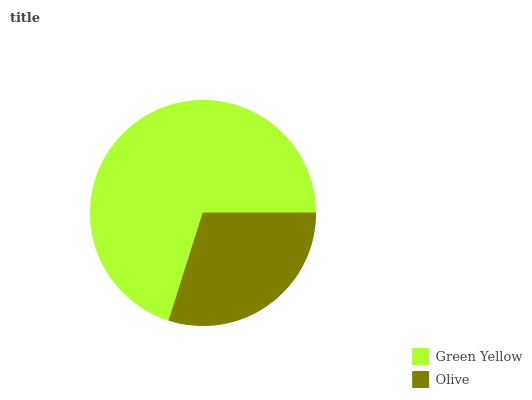Is Olive the minimum?
Answer yes or no. Yes. Is Green Yellow the maximum?
Answer yes or no. Yes. Is Olive the maximum?
Answer yes or no. No. Is Green Yellow greater than Olive?
Answer yes or no. Yes. Is Olive less than Green Yellow?
Answer yes or no. Yes. Is Olive greater than Green Yellow?
Answer yes or no. No. Is Green Yellow less than Olive?
Answer yes or no. No. Is Green Yellow the high median?
Answer yes or no. Yes. Is Olive the low median?
Answer yes or no. Yes. Is Olive the high median?
Answer yes or no. No. Is Green Yellow the low median?
Answer yes or no. No. 